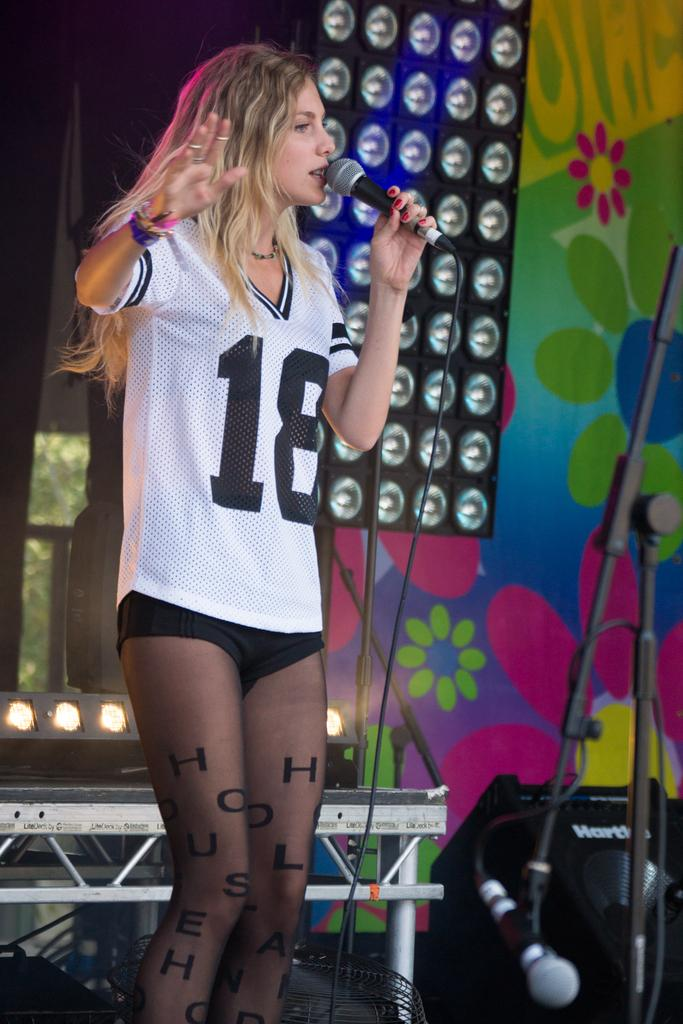Provide a one-sentence caption for the provided image. A woman wearing a white jersey with the number 18 on it sings into a microphone on stage. 